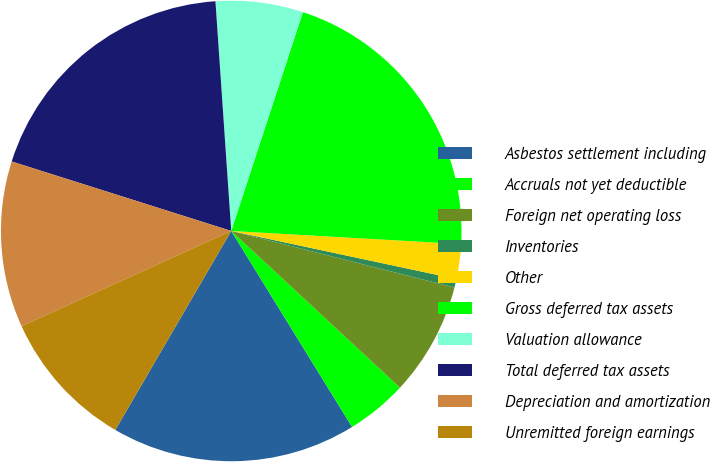Convert chart. <chart><loc_0><loc_0><loc_500><loc_500><pie_chart><fcel>Asbestos settlement including<fcel>Accruals not yet deductible<fcel>Foreign net operating loss<fcel>Inventories<fcel>Other<fcel>Gross deferred tax assets<fcel>Valuation allowance<fcel>Total deferred tax assets<fcel>Depreciation and amortization<fcel>Unremitted foreign earnings<nl><fcel>17.19%<fcel>4.29%<fcel>7.97%<fcel>0.6%<fcel>2.44%<fcel>20.87%<fcel>6.13%<fcel>19.03%<fcel>11.66%<fcel>9.82%<nl></chart> 